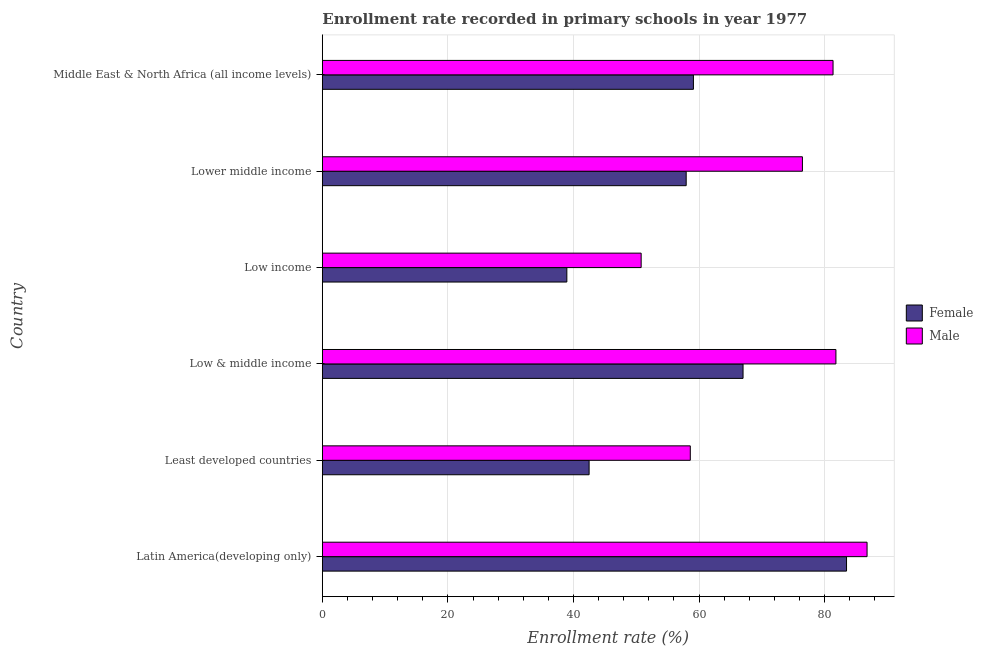Are the number of bars per tick equal to the number of legend labels?
Your answer should be very brief. Yes. In how many cases, is the number of bars for a given country not equal to the number of legend labels?
Give a very brief answer. 0. What is the enrollment rate of male students in Low & middle income?
Your answer should be very brief. 81.8. Across all countries, what is the maximum enrollment rate of female students?
Make the answer very short. 83.49. Across all countries, what is the minimum enrollment rate of female students?
Your answer should be very brief. 38.94. In which country was the enrollment rate of male students maximum?
Offer a very short reply. Latin America(developing only). In which country was the enrollment rate of female students minimum?
Give a very brief answer. Low income. What is the total enrollment rate of male students in the graph?
Your answer should be compact. 435.73. What is the difference between the enrollment rate of female students in Latin America(developing only) and that in Low income?
Make the answer very short. 44.54. What is the difference between the enrollment rate of female students in Low & middle income and the enrollment rate of male students in Low income?
Make the answer very short. 16.23. What is the average enrollment rate of female students per country?
Your response must be concise. 58.16. What is the difference between the enrollment rate of male students and enrollment rate of female students in Middle East & North Africa (all income levels)?
Ensure brevity in your answer.  22.24. What is the ratio of the enrollment rate of female students in Low & middle income to that in Low income?
Offer a very short reply. 1.72. Is the enrollment rate of female students in Least developed countries less than that in Lower middle income?
Make the answer very short. Yes. Is the difference between the enrollment rate of female students in Latin America(developing only) and Middle East & North Africa (all income levels) greater than the difference between the enrollment rate of male students in Latin America(developing only) and Middle East & North Africa (all income levels)?
Your response must be concise. Yes. What is the difference between the highest and the second highest enrollment rate of female students?
Ensure brevity in your answer.  16.48. What is the difference between the highest and the lowest enrollment rate of female students?
Provide a succinct answer. 44.54. What does the 1st bar from the bottom in Latin America(developing only) represents?
Keep it short and to the point. Female. Are all the bars in the graph horizontal?
Make the answer very short. Yes. How many countries are there in the graph?
Provide a succinct answer. 6. Where does the legend appear in the graph?
Your response must be concise. Center right. How many legend labels are there?
Ensure brevity in your answer.  2. What is the title of the graph?
Ensure brevity in your answer.  Enrollment rate recorded in primary schools in year 1977. Does "GDP at market prices" appear as one of the legend labels in the graph?
Your response must be concise. No. What is the label or title of the X-axis?
Your answer should be compact. Enrollment rate (%). What is the label or title of the Y-axis?
Offer a terse response. Country. What is the Enrollment rate (%) of Female in Latin America(developing only)?
Your answer should be compact. 83.49. What is the Enrollment rate (%) in Male in Latin America(developing only)?
Your answer should be very brief. 86.76. What is the Enrollment rate (%) of Female in Least developed countries?
Your answer should be compact. 42.49. What is the Enrollment rate (%) of Male in Least developed countries?
Your answer should be compact. 58.6. What is the Enrollment rate (%) in Female in Low & middle income?
Make the answer very short. 67. What is the Enrollment rate (%) in Male in Low & middle income?
Provide a short and direct response. 81.8. What is the Enrollment rate (%) in Female in Low income?
Provide a short and direct response. 38.94. What is the Enrollment rate (%) in Male in Low income?
Give a very brief answer. 50.78. What is the Enrollment rate (%) in Female in Lower middle income?
Ensure brevity in your answer.  57.95. What is the Enrollment rate (%) of Male in Lower middle income?
Provide a short and direct response. 76.46. What is the Enrollment rate (%) of Female in Middle East & North Africa (all income levels)?
Keep it short and to the point. 59.1. What is the Enrollment rate (%) in Male in Middle East & North Africa (all income levels)?
Provide a short and direct response. 81.34. Across all countries, what is the maximum Enrollment rate (%) in Female?
Offer a very short reply. 83.49. Across all countries, what is the maximum Enrollment rate (%) of Male?
Make the answer very short. 86.76. Across all countries, what is the minimum Enrollment rate (%) in Female?
Provide a succinct answer. 38.94. Across all countries, what is the minimum Enrollment rate (%) in Male?
Offer a terse response. 50.78. What is the total Enrollment rate (%) of Female in the graph?
Your answer should be compact. 348.97. What is the total Enrollment rate (%) of Male in the graph?
Keep it short and to the point. 435.73. What is the difference between the Enrollment rate (%) of Female in Latin America(developing only) and that in Least developed countries?
Ensure brevity in your answer.  41. What is the difference between the Enrollment rate (%) of Male in Latin America(developing only) and that in Least developed countries?
Provide a short and direct response. 28.15. What is the difference between the Enrollment rate (%) in Female in Latin America(developing only) and that in Low & middle income?
Ensure brevity in your answer.  16.48. What is the difference between the Enrollment rate (%) in Male in Latin America(developing only) and that in Low & middle income?
Your response must be concise. 4.96. What is the difference between the Enrollment rate (%) in Female in Latin America(developing only) and that in Low income?
Your answer should be very brief. 44.54. What is the difference between the Enrollment rate (%) in Male in Latin America(developing only) and that in Low income?
Your response must be concise. 35.98. What is the difference between the Enrollment rate (%) of Female in Latin America(developing only) and that in Lower middle income?
Give a very brief answer. 25.54. What is the difference between the Enrollment rate (%) of Male in Latin America(developing only) and that in Lower middle income?
Offer a terse response. 10.29. What is the difference between the Enrollment rate (%) in Female in Latin America(developing only) and that in Middle East & North Africa (all income levels)?
Your answer should be very brief. 24.38. What is the difference between the Enrollment rate (%) of Male in Latin America(developing only) and that in Middle East & North Africa (all income levels)?
Offer a terse response. 5.42. What is the difference between the Enrollment rate (%) in Female in Least developed countries and that in Low & middle income?
Provide a succinct answer. -24.52. What is the difference between the Enrollment rate (%) in Male in Least developed countries and that in Low & middle income?
Offer a terse response. -23.19. What is the difference between the Enrollment rate (%) of Female in Least developed countries and that in Low income?
Offer a very short reply. 3.55. What is the difference between the Enrollment rate (%) of Male in Least developed countries and that in Low income?
Offer a very short reply. 7.83. What is the difference between the Enrollment rate (%) of Female in Least developed countries and that in Lower middle income?
Keep it short and to the point. -15.46. What is the difference between the Enrollment rate (%) in Male in Least developed countries and that in Lower middle income?
Ensure brevity in your answer.  -17.86. What is the difference between the Enrollment rate (%) in Female in Least developed countries and that in Middle East & North Africa (all income levels)?
Give a very brief answer. -16.61. What is the difference between the Enrollment rate (%) of Male in Least developed countries and that in Middle East & North Africa (all income levels)?
Your response must be concise. -22.74. What is the difference between the Enrollment rate (%) of Female in Low & middle income and that in Low income?
Make the answer very short. 28.06. What is the difference between the Enrollment rate (%) in Male in Low & middle income and that in Low income?
Offer a very short reply. 31.02. What is the difference between the Enrollment rate (%) of Female in Low & middle income and that in Lower middle income?
Your response must be concise. 9.05. What is the difference between the Enrollment rate (%) of Male in Low & middle income and that in Lower middle income?
Offer a terse response. 5.33. What is the difference between the Enrollment rate (%) of Female in Low & middle income and that in Middle East & North Africa (all income levels)?
Provide a short and direct response. 7.9. What is the difference between the Enrollment rate (%) of Male in Low & middle income and that in Middle East & North Africa (all income levels)?
Make the answer very short. 0.46. What is the difference between the Enrollment rate (%) of Female in Low income and that in Lower middle income?
Your response must be concise. -19.01. What is the difference between the Enrollment rate (%) of Male in Low income and that in Lower middle income?
Give a very brief answer. -25.68. What is the difference between the Enrollment rate (%) of Female in Low income and that in Middle East & North Africa (all income levels)?
Offer a very short reply. -20.16. What is the difference between the Enrollment rate (%) in Male in Low income and that in Middle East & North Africa (all income levels)?
Keep it short and to the point. -30.56. What is the difference between the Enrollment rate (%) in Female in Lower middle income and that in Middle East & North Africa (all income levels)?
Your answer should be compact. -1.15. What is the difference between the Enrollment rate (%) in Male in Lower middle income and that in Middle East & North Africa (all income levels)?
Your answer should be compact. -4.88. What is the difference between the Enrollment rate (%) of Female in Latin America(developing only) and the Enrollment rate (%) of Male in Least developed countries?
Keep it short and to the point. 24.88. What is the difference between the Enrollment rate (%) in Female in Latin America(developing only) and the Enrollment rate (%) in Male in Low & middle income?
Ensure brevity in your answer.  1.69. What is the difference between the Enrollment rate (%) in Female in Latin America(developing only) and the Enrollment rate (%) in Male in Low income?
Make the answer very short. 32.71. What is the difference between the Enrollment rate (%) of Female in Latin America(developing only) and the Enrollment rate (%) of Male in Lower middle income?
Provide a succinct answer. 7.02. What is the difference between the Enrollment rate (%) of Female in Latin America(developing only) and the Enrollment rate (%) of Male in Middle East & North Africa (all income levels)?
Keep it short and to the point. 2.15. What is the difference between the Enrollment rate (%) in Female in Least developed countries and the Enrollment rate (%) in Male in Low & middle income?
Keep it short and to the point. -39.31. What is the difference between the Enrollment rate (%) of Female in Least developed countries and the Enrollment rate (%) of Male in Low income?
Make the answer very short. -8.29. What is the difference between the Enrollment rate (%) of Female in Least developed countries and the Enrollment rate (%) of Male in Lower middle income?
Give a very brief answer. -33.97. What is the difference between the Enrollment rate (%) of Female in Least developed countries and the Enrollment rate (%) of Male in Middle East & North Africa (all income levels)?
Offer a terse response. -38.85. What is the difference between the Enrollment rate (%) in Female in Low & middle income and the Enrollment rate (%) in Male in Low income?
Your response must be concise. 16.23. What is the difference between the Enrollment rate (%) in Female in Low & middle income and the Enrollment rate (%) in Male in Lower middle income?
Give a very brief answer. -9.46. What is the difference between the Enrollment rate (%) in Female in Low & middle income and the Enrollment rate (%) in Male in Middle East & North Africa (all income levels)?
Give a very brief answer. -14.33. What is the difference between the Enrollment rate (%) in Female in Low income and the Enrollment rate (%) in Male in Lower middle income?
Ensure brevity in your answer.  -37.52. What is the difference between the Enrollment rate (%) of Female in Low income and the Enrollment rate (%) of Male in Middle East & North Africa (all income levels)?
Provide a succinct answer. -42.4. What is the difference between the Enrollment rate (%) of Female in Lower middle income and the Enrollment rate (%) of Male in Middle East & North Africa (all income levels)?
Ensure brevity in your answer.  -23.39. What is the average Enrollment rate (%) of Female per country?
Ensure brevity in your answer.  58.16. What is the average Enrollment rate (%) of Male per country?
Your response must be concise. 72.62. What is the difference between the Enrollment rate (%) in Female and Enrollment rate (%) in Male in Latin America(developing only)?
Your answer should be compact. -3.27. What is the difference between the Enrollment rate (%) in Female and Enrollment rate (%) in Male in Least developed countries?
Your answer should be compact. -16.11. What is the difference between the Enrollment rate (%) of Female and Enrollment rate (%) of Male in Low & middle income?
Provide a succinct answer. -14.79. What is the difference between the Enrollment rate (%) of Female and Enrollment rate (%) of Male in Low income?
Offer a terse response. -11.84. What is the difference between the Enrollment rate (%) in Female and Enrollment rate (%) in Male in Lower middle income?
Your answer should be compact. -18.51. What is the difference between the Enrollment rate (%) of Female and Enrollment rate (%) of Male in Middle East & North Africa (all income levels)?
Keep it short and to the point. -22.24. What is the ratio of the Enrollment rate (%) of Female in Latin America(developing only) to that in Least developed countries?
Your answer should be very brief. 1.96. What is the ratio of the Enrollment rate (%) in Male in Latin America(developing only) to that in Least developed countries?
Provide a succinct answer. 1.48. What is the ratio of the Enrollment rate (%) of Female in Latin America(developing only) to that in Low & middle income?
Your response must be concise. 1.25. What is the ratio of the Enrollment rate (%) of Male in Latin America(developing only) to that in Low & middle income?
Provide a succinct answer. 1.06. What is the ratio of the Enrollment rate (%) in Female in Latin America(developing only) to that in Low income?
Offer a very short reply. 2.14. What is the ratio of the Enrollment rate (%) of Male in Latin America(developing only) to that in Low income?
Ensure brevity in your answer.  1.71. What is the ratio of the Enrollment rate (%) of Female in Latin America(developing only) to that in Lower middle income?
Ensure brevity in your answer.  1.44. What is the ratio of the Enrollment rate (%) in Male in Latin America(developing only) to that in Lower middle income?
Ensure brevity in your answer.  1.13. What is the ratio of the Enrollment rate (%) of Female in Latin America(developing only) to that in Middle East & North Africa (all income levels)?
Your answer should be very brief. 1.41. What is the ratio of the Enrollment rate (%) of Male in Latin America(developing only) to that in Middle East & North Africa (all income levels)?
Give a very brief answer. 1.07. What is the ratio of the Enrollment rate (%) in Female in Least developed countries to that in Low & middle income?
Your response must be concise. 0.63. What is the ratio of the Enrollment rate (%) in Male in Least developed countries to that in Low & middle income?
Offer a terse response. 0.72. What is the ratio of the Enrollment rate (%) of Female in Least developed countries to that in Low income?
Provide a short and direct response. 1.09. What is the ratio of the Enrollment rate (%) of Male in Least developed countries to that in Low income?
Give a very brief answer. 1.15. What is the ratio of the Enrollment rate (%) in Female in Least developed countries to that in Lower middle income?
Give a very brief answer. 0.73. What is the ratio of the Enrollment rate (%) of Male in Least developed countries to that in Lower middle income?
Keep it short and to the point. 0.77. What is the ratio of the Enrollment rate (%) in Female in Least developed countries to that in Middle East & North Africa (all income levels)?
Provide a succinct answer. 0.72. What is the ratio of the Enrollment rate (%) in Male in Least developed countries to that in Middle East & North Africa (all income levels)?
Your response must be concise. 0.72. What is the ratio of the Enrollment rate (%) of Female in Low & middle income to that in Low income?
Offer a terse response. 1.72. What is the ratio of the Enrollment rate (%) in Male in Low & middle income to that in Low income?
Keep it short and to the point. 1.61. What is the ratio of the Enrollment rate (%) of Female in Low & middle income to that in Lower middle income?
Your response must be concise. 1.16. What is the ratio of the Enrollment rate (%) in Male in Low & middle income to that in Lower middle income?
Give a very brief answer. 1.07. What is the ratio of the Enrollment rate (%) of Female in Low & middle income to that in Middle East & North Africa (all income levels)?
Provide a short and direct response. 1.13. What is the ratio of the Enrollment rate (%) of Male in Low & middle income to that in Middle East & North Africa (all income levels)?
Make the answer very short. 1.01. What is the ratio of the Enrollment rate (%) of Female in Low income to that in Lower middle income?
Keep it short and to the point. 0.67. What is the ratio of the Enrollment rate (%) in Male in Low income to that in Lower middle income?
Provide a succinct answer. 0.66. What is the ratio of the Enrollment rate (%) of Female in Low income to that in Middle East & North Africa (all income levels)?
Keep it short and to the point. 0.66. What is the ratio of the Enrollment rate (%) of Male in Low income to that in Middle East & North Africa (all income levels)?
Keep it short and to the point. 0.62. What is the ratio of the Enrollment rate (%) of Female in Lower middle income to that in Middle East & North Africa (all income levels)?
Your answer should be compact. 0.98. What is the ratio of the Enrollment rate (%) of Male in Lower middle income to that in Middle East & North Africa (all income levels)?
Offer a terse response. 0.94. What is the difference between the highest and the second highest Enrollment rate (%) of Female?
Offer a very short reply. 16.48. What is the difference between the highest and the second highest Enrollment rate (%) in Male?
Your answer should be compact. 4.96. What is the difference between the highest and the lowest Enrollment rate (%) of Female?
Your answer should be very brief. 44.54. What is the difference between the highest and the lowest Enrollment rate (%) of Male?
Your response must be concise. 35.98. 